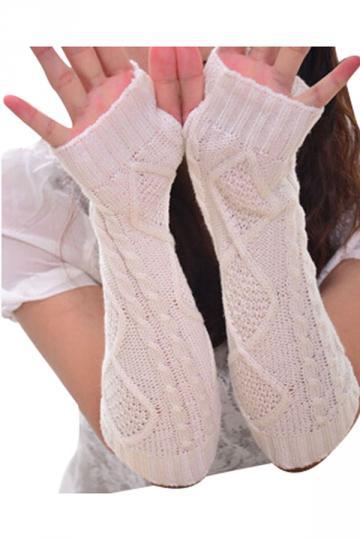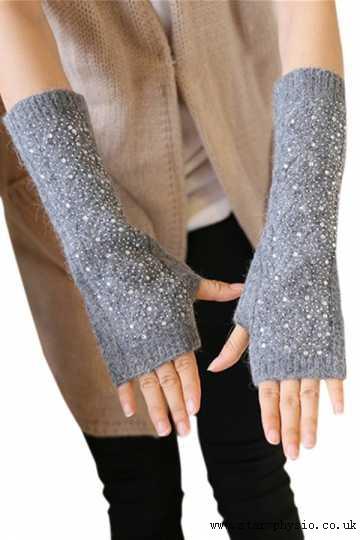The first image is the image on the left, the second image is the image on the right. Assess this claim about the two images: "Each image shows a pair of completely fingerless 'gloves' worn by a model, and the hands wearing gloves are posed fingers-up on the left, and fingers-down on the right.". Correct or not? Answer yes or no. Yes. The first image is the image on the left, the second image is the image on the right. Analyze the images presented: Is the assertion "A white pair of gloves is modeled on crossed hands, while a casual knit pair is modeled side by side." valid? Answer yes or no. No. 